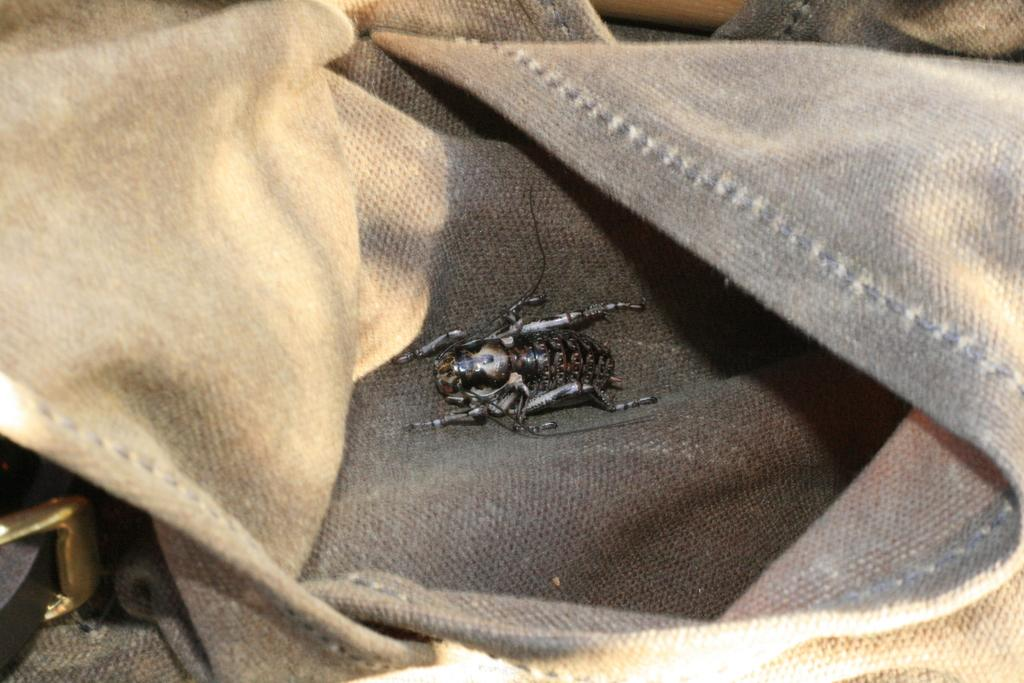What is the main object in the image? There is a cloth in the image. What is located on the cloth? There is an insect in the center of the cloth. What else can be seen in the image besides the cloth and insect? There are other objects visible in the background of the image. What type of box is being used to stimulate the brain in the image? There is no box or brain present in the image; it features a cloth with an insect in the center. 